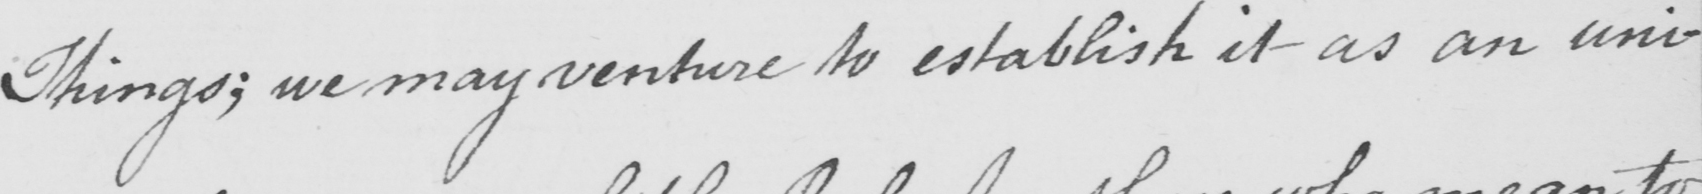Can you read and transcribe this handwriting? Things :  we may venture to establish it as an uni- 